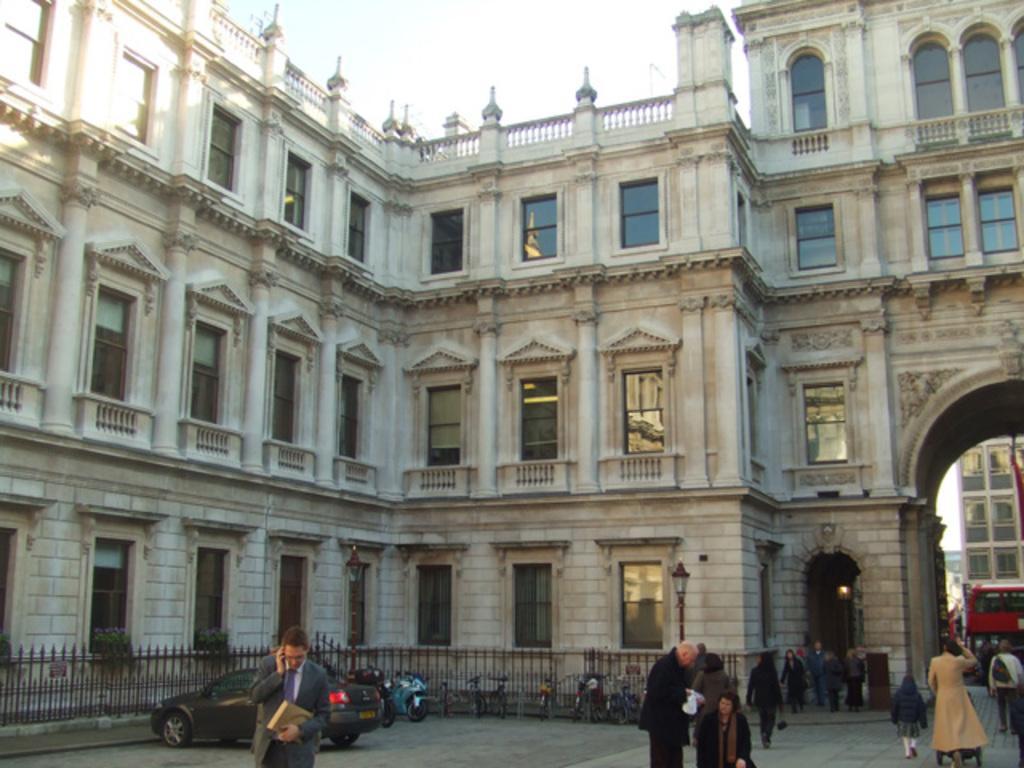Can you describe this image briefly? There is a building with windows, arches and railings. In the front of the building there is railing. On the sides of the building there are plants. There are cycles, scooters and a car is parked in front of the building. Also there are many people. 